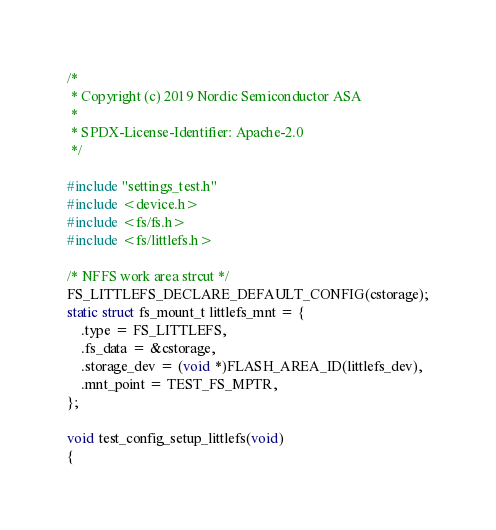Convert code to text. <code><loc_0><loc_0><loc_500><loc_500><_C_>/*
 * Copyright (c) 2019 Nordic Semiconductor ASA
 *
 * SPDX-License-Identifier: Apache-2.0
 */

#include "settings_test.h"
#include <device.h>
#include <fs/fs.h>
#include <fs/littlefs.h>

/* NFFS work area strcut */
FS_LITTLEFS_DECLARE_DEFAULT_CONFIG(cstorage);
static struct fs_mount_t littlefs_mnt = {
	.type = FS_LITTLEFS,
	.fs_data = &cstorage,
	.storage_dev = (void *)FLASH_AREA_ID(littlefs_dev),
	.mnt_point = TEST_FS_MPTR,
};

void test_config_setup_littlefs(void)
{</code> 